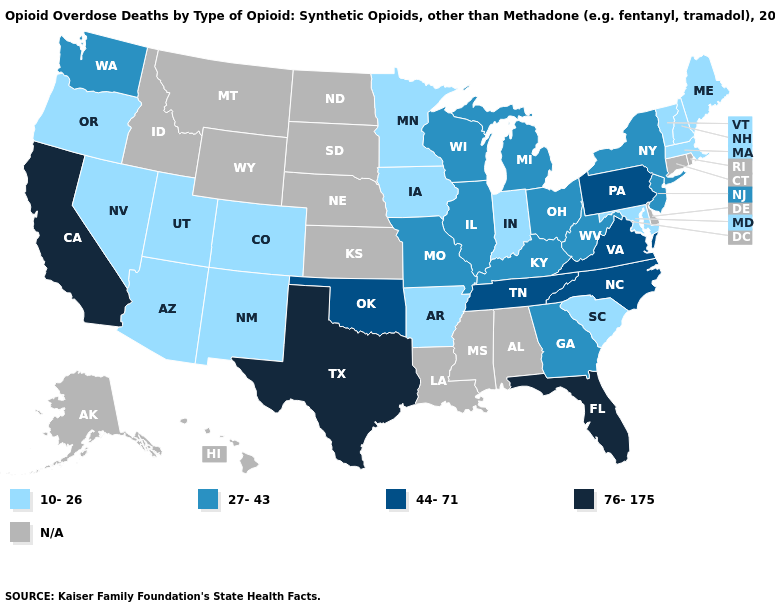Which states have the lowest value in the South?
Answer briefly. Arkansas, Maryland, South Carolina. Among the states that border New York , does Pennsylvania have the highest value?
Give a very brief answer. Yes. Name the states that have a value in the range 76-175?
Be succinct. California, Florida, Texas. Among the states that border Colorado , which have the lowest value?
Write a very short answer. Arizona, New Mexico, Utah. Does Colorado have the lowest value in the USA?
Quick response, please. Yes. What is the value of New York?
Concise answer only. 27-43. What is the value of Maryland?
Give a very brief answer. 10-26. What is the value of Louisiana?
Concise answer only. N/A. What is the value of California?
Answer briefly. 76-175. Name the states that have a value in the range 10-26?
Be succinct. Arizona, Arkansas, Colorado, Indiana, Iowa, Maine, Maryland, Massachusetts, Minnesota, Nevada, New Hampshire, New Mexico, Oregon, South Carolina, Utah, Vermont. Is the legend a continuous bar?
Concise answer only. No. Name the states that have a value in the range 10-26?
Write a very short answer. Arizona, Arkansas, Colorado, Indiana, Iowa, Maine, Maryland, Massachusetts, Minnesota, Nevada, New Hampshire, New Mexico, Oregon, South Carolina, Utah, Vermont. Does Florida have the highest value in the USA?
Keep it brief. Yes. Name the states that have a value in the range 44-71?
Give a very brief answer. North Carolina, Oklahoma, Pennsylvania, Tennessee, Virginia. Name the states that have a value in the range 27-43?
Give a very brief answer. Georgia, Illinois, Kentucky, Michigan, Missouri, New Jersey, New York, Ohio, Washington, West Virginia, Wisconsin. 